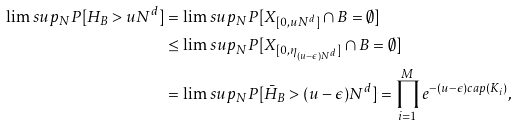<formula> <loc_0><loc_0><loc_500><loc_500>\lim s u p _ { N } P [ H _ { B } > u N ^ { d } ] & = \lim s u p _ { N } P [ X _ { [ 0 , u N ^ { d } ] } \cap B = \emptyset ] \\ & \leq \lim s u p _ { N } P [ X _ { [ 0 , \eta _ { ( u - \epsilon ) N ^ { d } } ] } \cap B = \emptyset ] \\ & = \lim s u p _ { N } P [ { \bar { H } } _ { B } > ( u - \epsilon ) N ^ { d } ] = \prod _ { i = 1 } ^ { M } e ^ { - ( u - \epsilon ) c a p ( K _ { i } ) } ,</formula> 